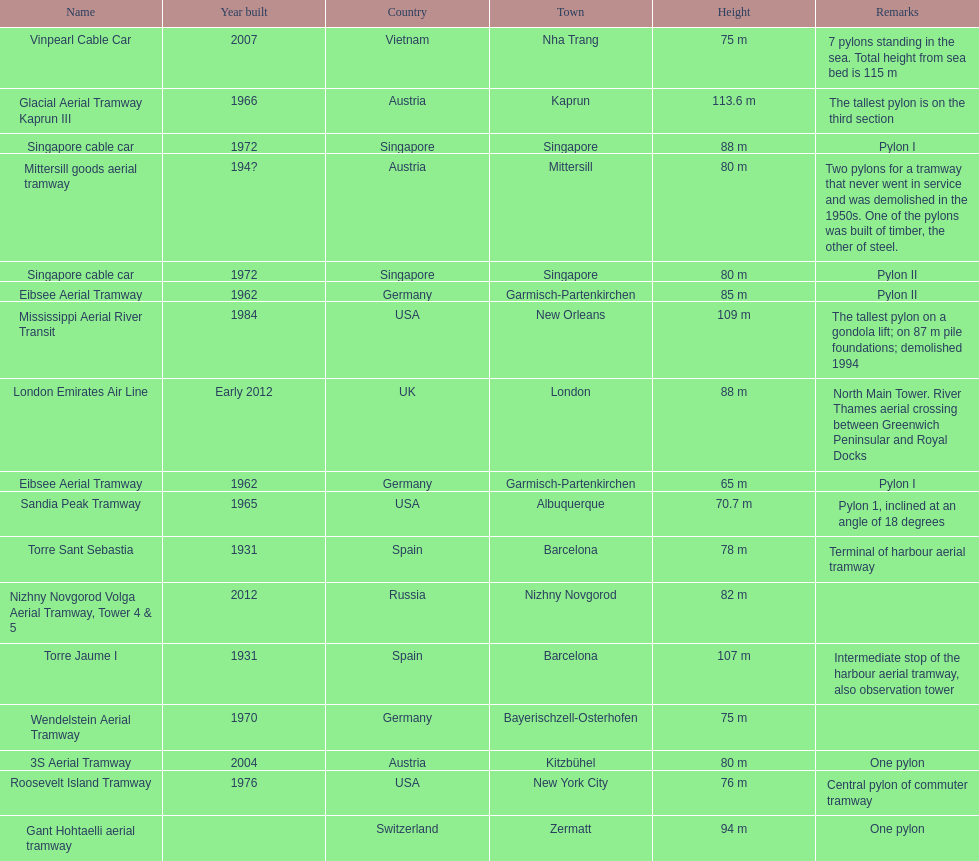List two pylons that are at most, 80 m in height. Mittersill goods aerial tramway, Singapore cable car. 